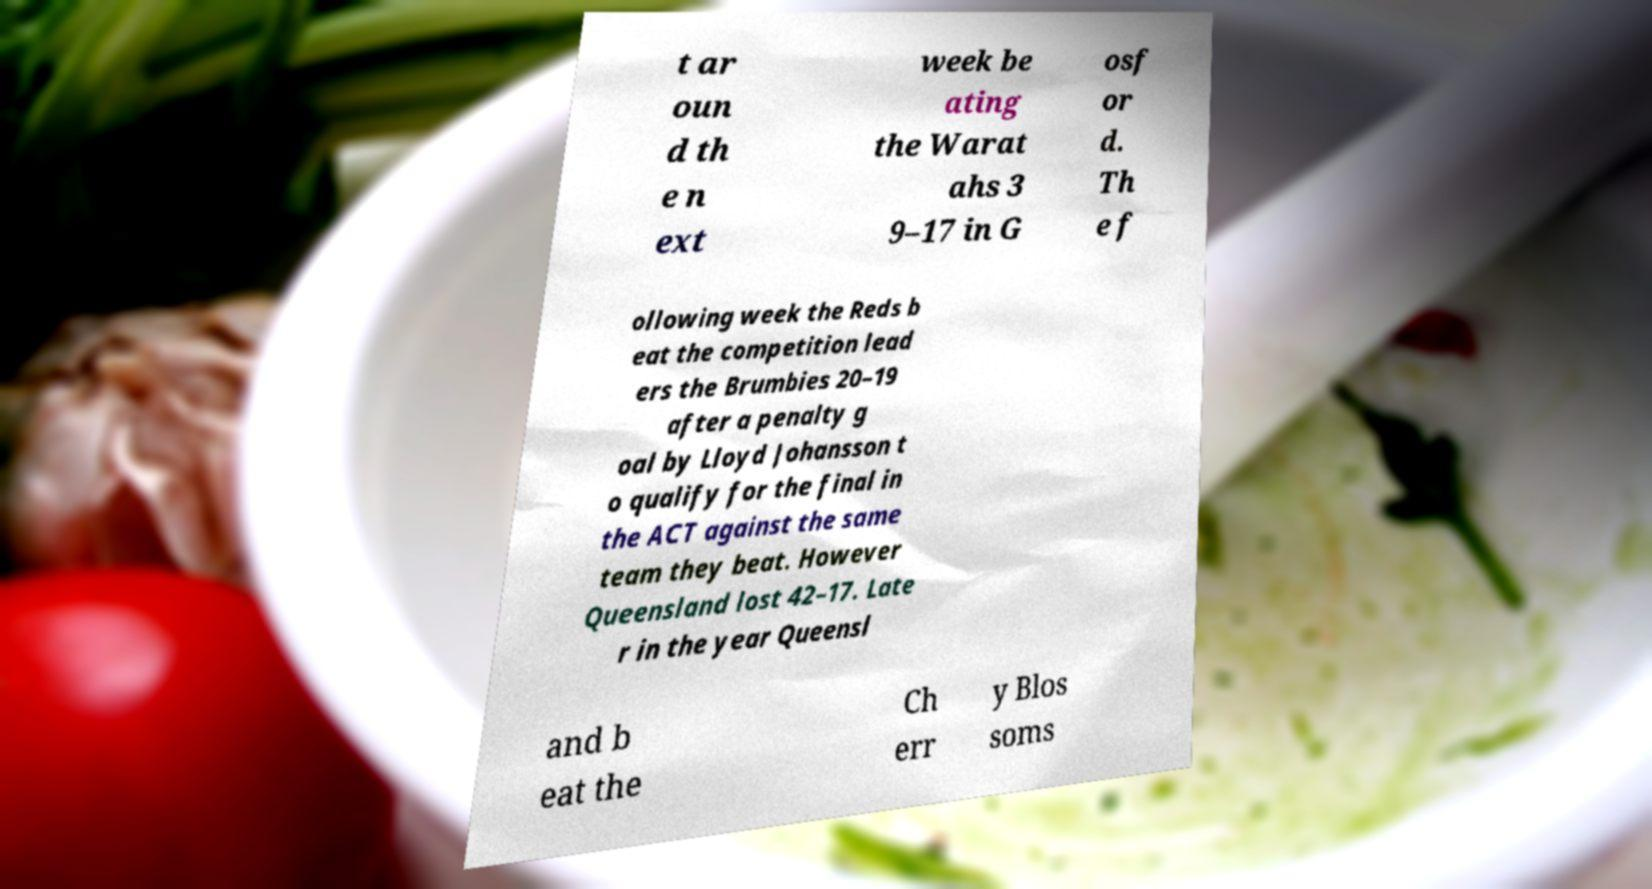Can you read and provide the text displayed in the image?This photo seems to have some interesting text. Can you extract and type it out for me? t ar oun d th e n ext week be ating the Warat ahs 3 9–17 in G osf or d. Th e f ollowing week the Reds b eat the competition lead ers the Brumbies 20–19 after a penalty g oal by Lloyd Johansson t o qualify for the final in the ACT against the same team they beat. However Queensland lost 42–17. Late r in the year Queensl and b eat the Ch err y Blos soms 